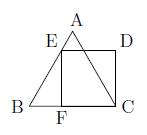How does the presence of square CDEF affect the properties or calculations related to triangle ABC? The presence of square $CDEF$, with specific corners touching the sides of triangle $ABC$, directly affects the calculations concerning the triangle. For instance, knowing the side length of square $CDEF$ helps us determine the length of the edges of triangle $ABC$. We can apply the Pythagorean theorem, where each side of the triangle is the hypotenuse formed by two sides of the square, offering a direct way to derive its sides and consequently calculate its area. Could you demonstrate using the Pythagorean theorem? Certainly! Considering that each side of the square is 1 unit, and it forms part of a right triangle where one side is along the edge of the triangle, and the hypotenuse is the side of the triangle itself. Let's say $s$ represents the length of a side of the triangle. By the Pythagorean theorem, $s^2 = 1^2 + 1^2 = 2$. Therefore, each side of the triangle $s = \sqrt{2}$. With this length, you can calculate the area or other properties relevant to the triangle. 